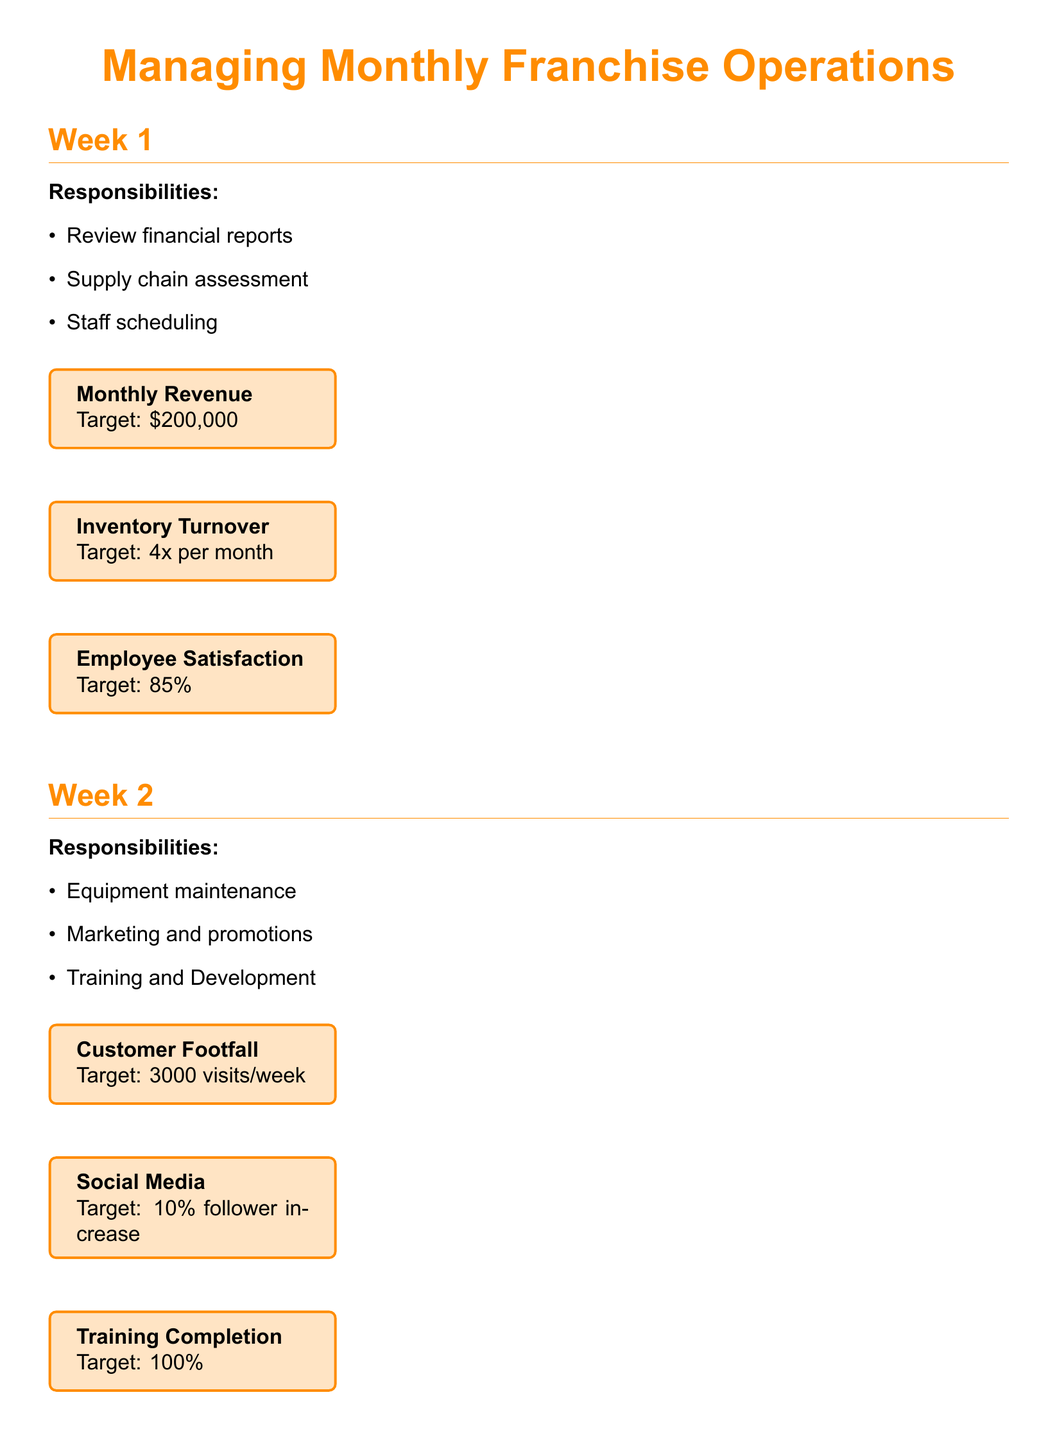What are the responsibilities for Week 1? The responsibilities listed for Week 1 are reviewing financial reports, supply chain assessment, and staff scheduling.
Answer: Review financial reports, supply chain assessment, staff scheduling What is the target for Monthly Revenue? The Monthly Revenue target is explicitly stated in the metrics box for Week 1.
Answer: $200,000 What is the Customer Satisfaction percentage? The Customer Satisfaction metric is found in the metrics box for Week 4.
Answer: 90% What key area is assessed during Week 2? Week 2 focuses on Equipment maintenance, Marketing and promotions, and Training and Development.
Answer: Equipment maintenance What is the Food Safety Score for Week 3? The Food Safety Score metric is specifically mentioned in Week 3's metrics box.
Answer: 100% How many community events are held per month? The number of community events per month is stated in the metrics box for Week 4.
Answer: 2 events/month What percentage reflects Employee Satisfaction? Employee Satisfaction is given in the metrics box for Week 1.
Answer: 85% What is the target for Social Media follower increase? The target for Social Media follower increase is specifically mentioned in the metrics box for Week 2.
Answer: 10% follower increase What week focuses on Strategic planning? Week 4 includes Strategic planning as one of its responsibilities.
Answer: Week 4 